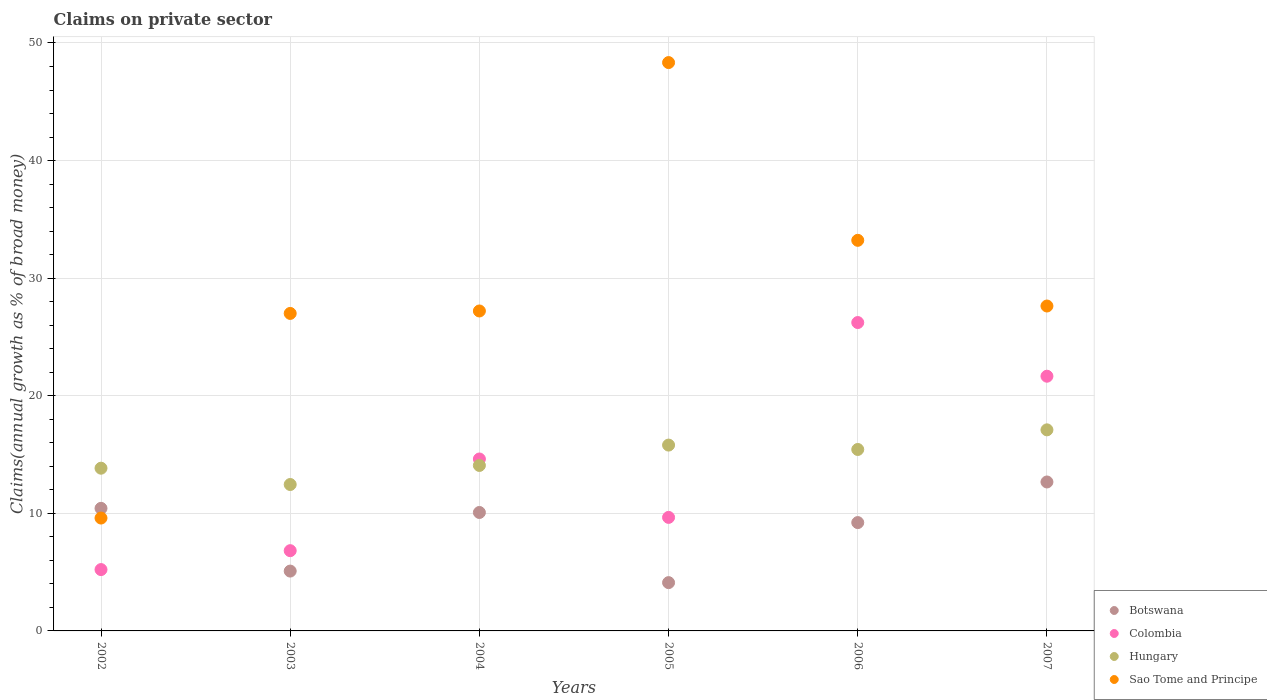Is the number of dotlines equal to the number of legend labels?
Give a very brief answer. Yes. What is the percentage of broad money claimed on private sector in Sao Tome and Principe in 2002?
Provide a succinct answer. 9.6. Across all years, what is the maximum percentage of broad money claimed on private sector in Colombia?
Your response must be concise. 26.22. Across all years, what is the minimum percentage of broad money claimed on private sector in Botswana?
Provide a short and direct response. 4.11. In which year was the percentage of broad money claimed on private sector in Hungary maximum?
Keep it short and to the point. 2007. What is the total percentage of broad money claimed on private sector in Botswana in the graph?
Provide a short and direct response. 51.57. What is the difference between the percentage of broad money claimed on private sector in Botswana in 2003 and that in 2006?
Your response must be concise. -4.12. What is the difference between the percentage of broad money claimed on private sector in Sao Tome and Principe in 2006 and the percentage of broad money claimed on private sector in Hungary in 2004?
Offer a terse response. 19.14. What is the average percentage of broad money claimed on private sector in Hungary per year?
Your response must be concise. 14.78. In the year 2005, what is the difference between the percentage of broad money claimed on private sector in Colombia and percentage of broad money claimed on private sector in Hungary?
Provide a short and direct response. -6.15. What is the ratio of the percentage of broad money claimed on private sector in Colombia in 2003 to that in 2006?
Provide a succinct answer. 0.26. Is the difference between the percentage of broad money claimed on private sector in Colombia in 2005 and 2006 greater than the difference between the percentage of broad money claimed on private sector in Hungary in 2005 and 2006?
Provide a short and direct response. No. What is the difference between the highest and the second highest percentage of broad money claimed on private sector in Colombia?
Ensure brevity in your answer.  4.56. What is the difference between the highest and the lowest percentage of broad money claimed on private sector in Colombia?
Make the answer very short. 21.01. In how many years, is the percentage of broad money claimed on private sector in Hungary greater than the average percentage of broad money claimed on private sector in Hungary taken over all years?
Your response must be concise. 3. Is the sum of the percentage of broad money claimed on private sector in Colombia in 2004 and 2005 greater than the maximum percentage of broad money claimed on private sector in Sao Tome and Principe across all years?
Ensure brevity in your answer.  No. Does the percentage of broad money claimed on private sector in Sao Tome and Principe monotonically increase over the years?
Your answer should be compact. No. Is the percentage of broad money claimed on private sector in Colombia strictly less than the percentage of broad money claimed on private sector in Botswana over the years?
Your answer should be compact. No. How many years are there in the graph?
Your answer should be compact. 6. Does the graph contain grids?
Your answer should be very brief. Yes. Where does the legend appear in the graph?
Give a very brief answer. Bottom right. How are the legend labels stacked?
Your response must be concise. Vertical. What is the title of the graph?
Make the answer very short. Claims on private sector. Does "Sudan" appear as one of the legend labels in the graph?
Make the answer very short. No. What is the label or title of the X-axis?
Provide a succinct answer. Years. What is the label or title of the Y-axis?
Your answer should be very brief. Claims(annual growth as % of broad money). What is the Claims(annual growth as % of broad money) in Botswana in 2002?
Provide a succinct answer. 10.42. What is the Claims(annual growth as % of broad money) of Colombia in 2002?
Provide a succinct answer. 5.22. What is the Claims(annual growth as % of broad money) in Hungary in 2002?
Ensure brevity in your answer.  13.84. What is the Claims(annual growth as % of broad money) in Sao Tome and Principe in 2002?
Your answer should be very brief. 9.6. What is the Claims(annual growth as % of broad money) in Botswana in 2003?
Provide a short and direct response. 5.09. What is the Claims(annual growth as % of broad money) in Colombia in 2003?
Offer a terse response. 6.82. What is the Claims(annual growth as % of broad money) in Hungary in 2003?
Your answer should be compact. 12.45. What is the Claims(annual growth as % of broad money) in Sao Tome and Principe in 2003?
Your answer should be very brief. 27. What is the Claims(annual growth as % of broad money) in Botswana in 2004?
Ensure brevity in your answer.  10.07. What is the Claims(annual growth as % of broad money) in Colombia in 2004?
Offer a terse response. 14.62. What is the Claims(annual growth as % of broad money) of Hungary in 2004?
Give a very brief answer. 14.07. What is the Claims(annual growth as % of broad money) in Sao Tome and Principe in 2004?
Ensure brevity in your answer.  27.21. What is the Claims(annual growth as % of broad money) in Botswana in 2005?
Your answer should be compact. 4.11. What is the Claims(annual growth as % of broad money) in Colombia in 2005?
Offer a very short reply. 9.66. What is the Claims(annual growth as % of broad money) of Hungary in 2005?
Offer a very short reply. 15.8. What is the Claims(annual growth as % of broad money) of Sao Tome and Principe in 2005?
Offer a very short reply. 48.33. What is the Claims(annual growth as % of broad money) of Botswana in 2006?
Ensure brevity in your answer.  9.21. What is the Claims(annual growth as % of broad money) in Colombia in 2006?
Your answer should be very brief. 26.22. What is the Claims(annual growth as % of broad money) in Hungary in 2006?
Give a very brief answer. 15.43. What is the Claims(annual growth as % of broad money) of Sao Tome and Principe in 2006?
Your answer should be compact. 33.22. What is the Claims(annual growth as % of broad money) of Botswana in 2007?
Your answer should be compact. 12.67. What is the Claims(annual growth as % of broad money) of Colombia in 2007?
Provide a short and direct response. 21.66. What is the Claims(annual growth as % of broad money) in Hungary in 2007?
Your answer should be very brief. 17.1. What is the Claims(annual growth as % of broad money) of Sao Tome and Principe in 2007?
Make the answer very short. 27.63. Across all years, what is the maximum Claims(annual growth as % of broad money) of Botswana?
Offer a very short reply. 12.67. Across all years, what is the maximum Claims(annual growth as % of broad money) in Colombia?
Offer a very short reply. 26.22. Across all years, what is the maximum Claims(annual growth as % of broad money) of Hungary?
Provide a succinct answer. 17.1. Across all years, what is the maximum Claims(annual growth as % of broad money) in Sao Tome and Principe?
Ensure brevity in your answer.  48.33. Across all years, what is the minimum Claims(annual growth as % of broad money) in Botswana?
Provide a short and direct response. 4.11. Across all years, what is the minimum Claims(annual growth as % of broad money) in Colombia?
Provide a succinct answer. 5.22. Across all years, what is the minimum Claims(annual growth as % of broad money) of Hungary?
Your answer should be compact. 12.45. Across all years, what is the minimum Claims(annual growth as % of broad money) of Sao Tome and Principe?
Your response must be concise. 9.6. What is the total Claims(annual growth as % of broad money) of Botswana in the graph?
Provide a succinct answer. 51.57. What is the total Claims(annual growth as % of broad money) of Colombia in the graph?
Your answer should be compact. 84.2. What is the total Claims(annual growth as % of broad money) in Hungary in the graph?
Provide a short and direct response. 88.7. What is the total Claims(annual growth as % of broad money) of Sao Tome and Principe in the graph?
Your answer should be compact. 172.99. What is the difference between the Claims(annual growth as % of broad money) in Botswana in 2002 and that in 2003?
Make the answer very short. 5.34. What is the difference between the Claims(annual growth as % of broad money) in Colombia in 2002 and that in 2003?
Provide a short and direct response. -1.61. What is the difference between the Claims(annual growth as % of broad money) of Hungary in 2002 and that in 2003?
Provide a short and direct response. 1.39. What is the difference between the Claims(annual growth as % of broad money) of Sao Tome and Principe in 2002 and that in 2003?
Offer a terse response. -17.4. What is the difference between the Claims(annual growth as % of broad money) of Botswana in 2002 and that in 2004?
Provide a short and direct response. 0.35. What is the difference between the Claims(annual growth as % of broad money) of Colombia in 2002 and that in 2004?
Offer a terse response. -9.4. What is the difference between the Claims(annual growth as % of broad money) of Hungary in 2002 and that in 2004?
Make the answer very short. -0.23. What is the difference between the Claims(annual growth as % of broad money) of Sao Tome and Principe in 2002 and that in 2004?
Offer a very short reply. -17.61. What is the difference between the Claims(annual growth as % of broad money) of Botswana in 2002 and that in 2005?
Make the answer very short. 6.32. What is the difference between the Claims(annual growth as % of broad money) in Colombia in 2002 and that in 2005?
Make the answer very short. -4.44. What is the difference between the Claims(annual growth as % of broad money) of Hungary in 2002 and that in 2005?
Your response must be concise. -1.97. What is the difference between the Claims(annual growth as % of broad money) of Sao Tome and Principe in 2002 and that in 2005?
Ensure brevity in your answer.  -38.73. What is the difference between the Claims(annual growth as % of broad money) of Botswana in 2002 and that in 2006?
Keep it short and to the point. 1.21. What is the difference between the Claims(annual growth as % of broad money) in Colombia in 2002 and that in 2006?
Your answer should be compact. -21.01. What is the difference between the Claims(annual growth as % of broad money) in Hungary in 2002 and that in 2006?
Provide a succinct answer. -1.59. What is the difference between the Claims(annual growth as % of broad money) of Sao Tome and Principe in 2002 and that in 2006?
Ensure brevity in your answer.  -23.62. What is the difference between the Claims(annual growth as % of broad money) in Botswana in 2002 and that in 2007?
Your answer should be compact. -2.24. What is the difference between the Claims(annual growth as % of broad money) of Colombia in 2002 and that in 2007?
Provide a succinct answer. -16.44. What is the difference between the Claims(annual growth as % of broad money) in Hungary in 2002 and that in 2007?
Offer a very short reply. -3.26. What is the difference between the Claims(annual growth as % of broad money) of Sao Tome and Principe in 2002 and that in 2007?
Offer a terse response. -18.03. What is the difference between the Claims(annual growth as % of broad money) of Botswana in 2003 and that in 2004?
Your answer should be very brief. -4.98. What is the difference between the Claims(annual growth as % of broad money) in Colombia in 2003 and that in 2004?
Provide a succinct answer. -7.8. What is the difference between the Claims(annual growth as % of broad money) in Hungary in 2003 and that in 2004?
Give a very brief answer. -1.62. What is the difference between the Claims(annual growth as % of broad money) of Sao Tome and Principe in 2003 and that in 2004?
Your answer should be compact. -0.21. What is the difference between the Claims(annual growth as % of broad money) of Botswana in 2003 and that in 2005?
Your answer should be very brief. 0.98. What is the difference between the Claims(annual growth as % of broad money) of Colombia in 2003 and that in 2005?
Offer a terse response. -2.83. What is the difference between the Claims(annual growth as % of broad money) of Hungary in 2003 and that in 2005?
Offer a very short reply. -3.35. What is the difference between the Claims(annual growth as % of broad money) in Sao Tome and Principe in 2003 and that in 2005?
Make the answer very short. -21.33. What is the difference between the Claims(annual growth as % of broad money) of Botswana in 2003 and that in 2006?
Offer a very short reply. -4.12. What is the difference between the Claims(annual growth as % of broad money) of Colombia in 2003 and that in 2006?
Provide a succinct answer. -19.4. What is the difference between the Claims(annual growth as % of broad money) of Hungary in 2003 and that in 2006?
Provide a succinct answer. -2.98. What is the difference between the Claims(annual growth as % of broad money) of Sao Tome and Principe in 2003 and that in 2006?
Offer a terse response. -6.22. What is the difference between the Claims(annual growth as % of broad money) of Botswana in 2003 and that in 2007?
Offer a very short reply. -7.58. What is the difference between the Claims(annual growth as % of broad money) in Colombia in 2003 and that in 2007?
Make the answer very short. -14.84. What is the difference between the Claims(annual growth as % of broad money) of Hungary in 2003 and that in 2007?
Ensure brevity in your answer.  -4.65. What is the difference between the Claims(annual growth as % of broad money) in Sao Tome and Principe in 2003 and that in 2007?
Give a very brief answer. -0.63. What is the difference between the Claims(annual growth as % of broad money) in Botswana in 2004 and that in 2005?
Provide a short and direct response. 5.97. What is the difference between the Claims(annual growth as % of broad money) of Colombia in 2004 and that in 2005?
Give a very brief answer. 4.97. What is the difference between the Claims(annual growth as % of broad money) in Hungary in 2004 and that in 2005?
Offer a very short reply. -1.73. What is the difference between the Claims(annual growth as % of broad money) in Sao Tome and Principe in 2004 and that in 2005?
Provide a succinct answer. -21.12. What is the difference between the Claims(annual growth as % of broad money) of Botswana in 2004 and that in 2006?
Provide a short and direct response. 0.86. What is the difference between the Claims(annual growth as % of broad money) in Colombia in 2004 and that in 2006?
Your response must be concise. -11.6. What is the difference between the Claims(annual growth as % of broad money) in Hungary in 2004 and that in 2006?
Your answer should be very brief. -1.36. What is the difference between the Claims(annual growth as % of broad money) of Sao Tome and Principe in 2004 and that in 2006?
Keep it short and to the point. -6.01. What is the difference between the Claims(annual growth as % of broad money) in Botswana in 2004 and that in 2007?
Give a very brief answer. -2.59. What is the difference between the Claims(annual growth as % of broad money) in Colombia in 2004 and that in 2007?
Your answer should be very brief. -7.04. What is the difference between the Claims(annual growth as % of broad money) of Hungary in 2004 and that in 2007?
Your answer should be compact. -3.03. What is the difference between the Claims(annual growth as % of broad money) in Sao Tome and Principe in 2004 and that in 2007?
Provide a succinct answer. -0.42. What is the difference between the Claims(annual growth as % of broad money) of Botswana in 2005 and that in 2006?
Your response must be concise. -5.11. What is the difference between the Claims(annual growth as % of broad money) of Colombia in 2005 and that in 2006?
Keep it short and to the point. -16.57. What is the difference between the Claims(annual growth as % of broad money) in Hungary in 2005 and that in 2006?
Provide a short and direct response. 0.37. What is the difference between the Claims(annual growth as % of broad money) in Sao Tome and Principe in 2005 and that in 2006?
Provide a succinct answer. 15.12. What is the difference between the Claims(annual growth as % of broad money) in Botswana in 2005 and that in 2007?
Make the answer very short. -8.56. What is the difference between the Claims(annual growth as % of broad money) of Colombia in 2005 and that in 2007?
Provide a short and direct response. -12.01. What is the difference between the Claims(annual growth as % of broad money) in Hungary in 2005 and that in 2007?
Your answer should be compact. -1.3. What is the difference between the Claims(annual growth as % of broad money) in Sao Tome and Principe in 2005 and that in 2007?
Offer a terse response. 20.7. What is the difference between the Claims(annual growth as % of broad money) in Botswana in 2006 and that in 2007?
Make the answer very short. -3.45. What is the difference between the Claims(annual growth as % of broad money) in Colombia in 2006 and that in 2007?
Ensure brevity in your answer.  4.56. What is the difference between the Claims(annual growth as % of broad money) of Hungary in 2006 and that in 2007?
Keep it short and to the point. -1.67. What is the difference between the Claims(annual growth as % of broad money) in Sao Tome and Principe in 2006 and that in 2007?
Offer a very short reply. 5.59. What is the difference between the Claims(annual growth as % of broad money) of Botswana in 2002 and the Claims(annual growth as % of broad money) of Colombia in 2003?
Offer a very short reply. 3.6. What is the difference between the Claims(annual growth as % of broad money) in Botswana in 2002 and the Claims(annual growth as % of broad money) in Hungary in 2003?
Ensure brevity in your answer.  -2.03. What is the difference between the Claims(annual growth as % of broad money) in Botswana in 2002 and the Claims(annual growth as % of broad money) in Sao Tome and Principe in 2003?
Keep it short and to the point. -16.58. What is the difference between the Claims(annual growth as % of broad money) in Colombia in 2002 and the Claims(annual growth as % of broad money) in Hungary in 2003?
Provide a short and direct response. -7.24. What is the difference between the Claims(annual growth as % of broad money) in Colombia in 2002 and the Claims(annual growth as % of broad money) in Sao Tome and Principe in 2003?
Give a very brief answer. -21.78. What is the difference between the Claims(annual growth as % of broad money) in Hungary in 2002 and the Claims(annual growth as % of broad money) in Sao Tome and Principe in 2003?
Ensure brevity in your answer.  -13.16. What is the difference between the Claims(annual growth as % of broad money) in Botswana in 2002 and the Claims(annual growth as % of broad money) in Colombia in 2004?
Give a very brief answer. -4.2. What is the difference between the Claims(annual growth as % of broad money) of Botswana in 2002 and the Claims(annual growth as % of broad money) of Hungary in 2004?
Give a very brief answer. -3.65. What is the difference between the Claims(annual growth as % of broad money) in Botswana in 2002 and the Claims(annual growth as % of broad money) in Sao Tome and Principe in 2004?
Offer a terse response. -16.78. What is the difference between the Claims(annual growth as % of broad money) in Colombia in 2002 and the Claims(annual growth as % of broad money) in Hungary in 2004?
Make the answer very short. -8.86. What is the difference between the Claims(annual growth as % of broad money) of Colombia in 2002 and the Claims(annual growth as % of broad money) of Sao Tome and Principe in 2004?
Provide a short and direct response. -21.99. What is the difference between the Claims(annual growth as % of broad money) in Hungary in 2002 and the Claims(annual growth as % of broad money) in Sao Tome and Principe in 2004?
Give a very brief answer. -13.37. What is the difference between the Claims(annual growth as % of broad money) of Botswana in 2002 and the Claims(annual growth as % of broad money) of Colombia in 2005?
Offer a very short reply. 0.77. What is the difference between the Claims(annual growth as % of broad money) in Botswana in 2002 and the Claims(annual growth as % of broad money) in Hungary in 2005?
Provide a succinct answer. -5.38. What is the difference between the Claims(annual growth as % of broad money) in Botswana in 2002 and the Claims(annual growth as % of broad money) in Sao Tome and Principe in 2005?
Ensure brevity in your answer.  -37.91. What is the difference between the Claims(annual growth as % of broad money) of Colombia in 2002 and the Claims(annual growth as % of broad money) of Hungary in 2005?
Provide a short and direct response. -10.59. What is the difference between the Claims(annual growth as % of broad money) of Colombia in 2002 and the Claims(annual growth as % of broad money) of Sao Tome and Principe in 2005?
Provide a short and direct response. -43.12. What is the difference between the Claims(annual growth as % of broad money) of Hungary in 2002 and the Claims(annual growth as % of broad money) of Sao Tome and Principe in 2005?
Keep it short and to the point. -34.49. What is the difference between the Claims(annual growth as % of broad money) of Botswana in 2002 and the Claims(annual growth as % of broad money) of Colombia in 2006?
Give a very brief answer. -15.8. What is the difference between the Claims(annual growth as % of broad money) of Botswana in 2002 and the Claims(annual growth as % of broad money) of Hungary in 2006?
Your answer should be very brief. -5.01. What is the difference between the Claims(annual growth as % of broad money) in Botswana in 2002 and the Claims(annual growth as % of broad money) in Sao Tome and Principe in 2006?
Offer a terse response. -22.79. What is the difference between the Claims(annual growth as % of broad money) in Colombia in 2002 and the Claims(annual growth as % of broad money) in Hungary in 2006?
Ensure brevity in your answer.  -10.21. What is the difference between the Claims(annual growth as % of broad money) in Colombia in 2002 and the Claims(annual growth as % of broad money) in Sao Tome and Principe in 2006?
Offer a very short reply. -28. What is the difference between the Claims(annual growth as % of broad money) of Hungary in 2002 and the Claims(annual growth as % of broad money) of Sao Tome and Principe in 2006?
Your response must be concise. -19.38. What is the difference between the Claims(annual growth as % of broad money) in Botswana in 2002 and the Claims(annual growth as % of broad money) in Colombia in 2007?
Make the answer very short. -11.24. What is the difference between the Claims(annual growth as % of broad money) in Botswana in 2002 and the Claims(annual growth as % of broad money) in Hungary in 2007?
Provide a short and direct response. -6.68. What is the difference between the Claims(annual growth as % of broad money) in Botswana in 2002 and the Claims(annual growth as % of broad money) in Sao Tome and Principe in 2007?
Make the answer very short. -17.21. What is the difference between the Claims(annual growth as % of broad money) of Colombia in 2002 and the Claims(annual growth as % of broad money) of Hungary in 2007?
Make the answer very short. -11.88. What is the difference between the Claims(annual growth as % of broad money) in Colombia in 2002 and the Claims(annual growth as % of broad money) in Sao Tome and Principe in 2007?
Your answer should be compact. -22.41. What is the difference between the Claims(annual growth as % of broad money) of Hungary in 2002 and the Claims(annual growth as % of broad money) of Sao Tome and Principe in 2007?
Make the answer very short. -13.79. What is the difference between the Claims(annual growth as % of broad money) in Botswana in 2003 and the Claims(annual growth as % of broad money) in Colombia in 2004?
Your answer should be compact. -9.53. What is the difference between the Claims(annual growth as % of broad money) in Botswana in 2003 and the Claims(annual growth as % of broad money) in Hungary in 2004?
Your response must be concise. -8.98. What is the difference between the Claims(annual growth as % of broad money) of Botswana in 2003 and the Claims(annual growth as % of broad money) of Sao Tome and Principe in 2004?
Give a very brief answer. -22.12. What is the difference between the Claims(annual growth as % of broad money) in Colombia in 2003 and the Claims(annual growth as % of broad money) in Hungary in 2004?
Offer a very short reply. -7.25. What is the difference between the Claims(annual growth as % of broad money) in Colombia in 2003 and the Claims(annual growth as % of broad money) in Sao Tome and Principe in 2004?
Your answer should be compact. -20.38. What is the difference between the Claims(annual growth as % of broad money) in Hungary in 2003 and the Claims(annual growth as % of broad money) in Sao Tome and Principe in 2004?
Your answer should be compact. -14.76. What is the difference between the Claims(annual growth as % of broad money) in Botswana in 2003 and the Claims(annual growth as % of broad money) in Colombia in 2005?
Provide a short and direct response. -4.57. What is the difference between the Claims(annual growth as % of broad money) in Botswana in 2003 and the Claims(annual growth as % of broad money) in Hungary in 2005?
Offer a very short reply. -10.72. What is the difference between the Claims(annual growth as % of broad money) of Botswana in 2003 and the Claims(annual growth as % of broad money) of Sao Tome and Principe in 2005?
Your answer should be very brief. -43.24. What is the difference between the Claims(annual growth as % of broad money) in Colombia in 2003 and the Claims(annual growth as % of broad money) in Hungary in 2005?
Ensure brevity in your answer.  -8.98. What is the difference between the Claims(annual growth as % of broad money) of Colombia in 2003 and the Claims(annual growth as % of broad money) of Sao Tome and Principe in 2005?
Offer a terse response. -41.51. What is the difference between the Claims(annual growth as % of broad money) in Hungary in 2003 and the Claims(annual growth as % of broad money) in Sao Tome and Principe in 2005?
Offer a very short reply. -35.88. What is the difference between the Claims(annual growth as % of broad money) of Botswana in 2003 and the Claims(annual growth as % of broad money) of Colombia in 2006?
Give a very brief answer. -21.14. What is the difference between the Claims(annual growth as % of broad money) in Botswana in 2003 and the Claims(annual growth as % of broad money) in Hungary in 2006?
Keep it short and to the point. -10.34. What is the difference between the Claims(annual growth as % of broad money) of Botswana in 2003 and the Claims(annual growth as % of broad money) of Sao Tome and Principe in 2006?
Make the answer very short. -28.13. What is the difference between the Claims(annual growth as % of broad money) of Colombia in 2003 and the Claims(annual growth as % of broad money) of Hungary in 2006?
Provide a succinct answer. -8.61. What is the difference between the Claims(annual growth as % of broad money) in Colombia in 2003 and the Claims(annual growth as % of broad money) in Sao Tome and Principe in 2006?
Offer a terse response. -26.39. What is the difference between the Claims(annual growth as % of broad money) of Hungary in 2003 and the Claims(annual growth as % of broad money) of Sao Tome and Principe in 2006?
Ensure brevity in your answer.  -20.77. What is the difference between the Claims(annual growth as % of broad money) of Botswana in 2003 and the Claims(annual growth as % of broad money) of Colombia in 2007?
Your response must be concise. -16.57. What is the difference between the Claims(annual growth as % of broad money) of Botswana in 2003 and the Claims(annual growth as % of broad money) of Hungary in 2007?
Provide a succinct answer. -12.01. What is the difference between the Claims(annual growth as % of broad money) of Botswana in 2003 and the Claims(annual growth as % of broad money) of Sao Tome and Principe in 2007?
Your response must be concise. -22.54. What is the difference between the Claims(annual growth as % of broad money) in Colombia in 2003 and the Claims(annual growth as % of broad money) in Hungary in 2007?
Offer a terse response. -10.28. What is the difference between the Claims(annual growth as % of broad money) of Colombia in 2003 and the Claims(annual growth as % of broad money) of Sao Tome and Principe in 2007?
Make the answer very short. -20.81. What is the difference between the Claims(annual growth as % of broad money) of Hungary in 2003 and the Claims(annual growth as % of broad money) of Sao Tome and Principe in 2007?
Offer a terse response. -15.18. What is the difference between the Claims(annual growth as % of broad money) in Botswana in 2004 and the Claims(annual growth as % of broad money) in Colombia in 2005?
Provide a short and direct response. 0.42. What is the difference between the Claims(annual growth as % of broad money) in Botswana in 2004 and the Claims(annual growth as % of broad money) in Hungary in 2005?
Provide a succinct answer. -5.73. What is the difference between the Claims(annual growth as % of broad money) in Botswana in 2004 and the Claims(annual growth as % of broad money) in Sao Tome and Principe in 2005?
Keep it short and to the point. -38.26. What is the difference between the Claims(annual growth as % of broad money) of Colombia in 2004 and the Claims(annual growth as % of broad money) of Hungary in 2005?
Provide a succinct answer. -1.18. What is the difference between the Claims(annual growth as % of broad money) in Colombia in 2004 and the Claims(annual growth as % of broad money) in Sao Tome and Principe in 2005?
Give a very brief answer. -33.71. What is the difference between the Claims(annual growth as % of broad money) of Hungary in 2004 and the Claims(annual growth as % of broad money) of Sao Tome and Principe in 2005?
Your answer should be compact. -34.26. What is the difference between the Claims(annual growth as % of broad money) in Botswana in 2004 and the Claims(annual growth as % of broad money) in Colombia in 2006?
Make the answer very short. -16.15. What is the difference between the Claims(annual growth as % of broad money) in Botswana in 2004 and the Claims(annual growth as % of broad money) in Hungary in 2006?
Make the answer very short. -5.36. What is the difference between the Claims(annual growth as % of broad money) of Botswana in 2004 and the Claims(annual growth as % of broad money) of Sao Tome and Principe in 2006?
Make the answer very short. -23.14. What is the difference between the Claims(annual growth as % of broad money) of Colombia in 2004 and the Claims(annual growth as % of broad money) of Hungary in 2006?
Ensure brevity in your answer.  -0.81. What is the difference between the Claims(annual growth as % of broad money) in Colombia in 2004 and the Claims(annual growth as % of broad money) in Sao Tome and Principe in 2006?
Offer a very short reply. -18.6. What is the difference between the Claims(annual growth as % of broad money) in Hungary in 2004 and the Claims(annual growth as % of broad money) in Sao Tome and Principe in 2006?
Make the answer very short. -19.14. What is the difference between the Claims(annual growth as % of broad money) in Botswana in 2004 and the Claims(annual growth as % of broad money) in Colombia in 2007?
Offer a terse response. -11.59. What is the difference between the Claims(annual growth as % of broad money) in Botswana in 2004 and the Claims(annual growth as % of broad money) in Hungary in 2007?
Your response must be concise. -7.03. What is the difference between the Claims(annual growth as % of broad money) in Botswana in 2004 and the Claims(annual growth as % of broad money) in Sao Tome and Principe in 2007?
Your response must be concise. -17.56. What is the difference between the Claims(annual growth as % of broad money) in Colombia in 2004 and the Claims(annual growth as % of broad money) in Hungary in 2007?
Your response must be concise. -2.48. What is the difference between the Claims(annual growth as % of broad money) in Colombia in 2004 and the Claims(annual growth as % of broad money) in Sao Tome and Principe in 2007?
Your response must be concise. -13.01. What is the difference between the Claims(annual growth as % of broad money) in Hungary in 2004 and the Claims(annual growth as % of broad money) in Sao Tome and Principe in 2007?
Offer a very short reply. -13.56. What is the difference between the Claims(annual growth as % of broad money) of Botswana in 2005 and the Claims(annual growth as % of broad money) of Colombia in 2006?
Offer a very short reply. -22.12. What is the difference between the Claims(annual growth as % of broad money) of Botswana in 2005 and the Claims(annual growth as % of broad money) of Hungary in 2006?
Provide a short and direct response. -11.32. What is the difference between the Claims(annual growth as % of broad money) of Botswana in 2005 and the Claims(annual growth as % of broad money) of Sao Tome and Principe in 2006?
Make the answer very short. -29.11. What is the difference between the Claims(annual growth as % of broad money) of Colombia in 2005 and the Claims(annual growth as % of broad money) of Hungary in 2006?
Keep it short and to the point. -5.78. What is the difference between the Claims(annual growth as % of broad money) of Colombia in 2005 and the Claims(annual growth as % of broad money) of Sao Tome and Principe in 2006?
Offer a terse response. -23.56. What is the difference between the Claims(annual growth as % of broad money) of Hungary in 2005 and the Claims(annual growth as % of broad money) of Sao Tome and Principe in 2006?
Offer a terse response. -17.41. What is the difference between the Claims(annual growth as % of broad money) of Botswana in 2005 and the Claims(annual growth as % of broad money) of Colombia in 2007?
Make the answer very short. -17.55. What is the difference between the Claims(annual growth as % of broad money) of Botswana in 2005 and the Claims(annual growth as % of broad money) of Hungary in 2007?
Make the answer very short. -12.99. What is the difference between the Claims(annual growth as % of broad money) in Botswana in 2005 and the Claims(annual growth as % of broad money) in Sao Tome and Principe in 2007?
Your answer should be very brief. -23.52. What is the difference between the Claims(annual growth as % of broad money) in Colombia in 2005 and the Claims(annual growth as % of broad money) in Hungary in 2007?
Provide a succinct answer. -7.44. What is the difference between the Claims(annual growth as % of broad money) of Colombia in 2005 and the Claims(annual growth as % of broad money) of Sao Tome and Principe in 2007?
Provide a succinct answer. -17.98. What is the difference between the Claims(annual growth as % of broad money) in Hungary in 2005 and the Claims(annual growth as % of broad money) in Sao Tome and Principe in 2007?
Your answer should be very brief. -11.83. What is the difference between the Claims(annual growth as % of broad money) in Botswana in 2006 and the Claims(annual growth as % of broad money) in Colombia in 2007?
Keep it short and to the point. -12.45. What is the difference between the Claims(annual growth as % of broad money) of Botswana in 2006 and the Claims(annual growth as % of broad money) of Hungary in 2007?
Provide a succinct answer. -7.89. What is the difference between the Claims(annual growth as % of broad money) in Botswana in 2006 and the Claims(annual growth as % of broad money) in Sao Tome and Principe in 2007?
Make the answer very short. -18.42. What is the difference between the Claims(annual growth as % of broad money) in Colombia in 2006 and the Claims(annual growth as % of broad money) in Hungary in 2007?
Offer a very short reply. 9.13. What is the difference between the Claims(annual growth as % of broad money) in Colombia in 2006 and the Claims(annual growth as % of broad money) in Sao Tome and Principe in 2007?
Your response must be concise. -1.41. What is the difference between the Claims(annual growth as % of broad money) in Hungary in 2006 and the Claims(annual growth as % of broad money) in Sao Tome and Principe in 2007?
Your answer should be compact. -12.2. What is the average Claims(annual growth as % of broad money) in Botswana per year?
Provide a succinct answer. 8.6. What is the average Claims(annual growth as % of broad money) in Colombia per year?
Your response must be concise. 14.03. What is the average Claims(annual growth as % of broad money) in Hungary per year?
Offer a terse response. 14.78. What is the average Claims(annual growth as % of broad money) of Sao Tome and Principe per year?
Give a very brief answer. 28.83. In the year 2002, what is the difference between the Claims(annual growth as % of broad money) in Botswana and Claims(annual growth as % of broad money) in Colombia?
Offer a terse response. 5.21. In the year 2002, what is the difference between the Claims(annual growth as % of broad money) in Botswana and Claims(annual growth as % of broad money) in Hungary?
Provide a short and direct response. -3.41. In the year 2002, what is the difference between the Claims(annual growth as % of broad money) in Botswana and Claims(annual growth as % of broad money) in Sao Tome and Principe?
Your answer should be very brief. 0.83. In the year 2002, what is the difference between the Claims(annual growth as % of broad money) of Colombia and Claims(annual growth as % of broad money) of Hungary?
Keep it short and to the point. -8.62. In the year 2002, what is the difference between the Claims(annual growth as % of broad money) in Colombia and Claims(annual growth as % of broad money) in Sao Tome and Principe?
Your answer should be very brief. -4.38. In the year 2002, what is the difference between the Claims(annual growth as % of broad money) in Hungary and Claims(annual growth as % of broad money) in Sao Tome and Principe?
Your answer should be very brief. 4.24. In the year 2003, what is the difference between the Claims(annual growth as % of broad money) in Botswana and Claims(annual growth as % of broad money) in Colombia?
Offer a very short reply. -1.74. In the year 2003, what is the difference between the Claims(annual growth as % of broad money) in Botswana and Claims(annual growth as % of broad money) in Hungary?
Offer a very short reply. -7.36. In the year 2003, what is the difference between the Claims(annual growth as % of broad money) in Botswana and Claims(annual growth as % of broad money) in Sao Tome and Principe?
Keep it short and to the point. -21.91. In the year 2003, what is the difference between the Claims(annual growth as % of broad money) of Colombia and Claims(annual growth as % of broad money) of Hungary?
Your answer should be very brief. -5.63. In the year 2003, what is the difference between the Claims(annual growth as % of broad money) in Colombia and Claims(annual growth as % of broad money) in Sao Tome and Principe?
Offer a terse response. -20.18. In the year 2003, what is the difference between the Claims(annual growth as % of broad money) in Hungary and Claims(annual growth as % of broad money) in Sao Tome and Principe?
Your answer should be compact. -14.55. In the year 2004, what is the difference between the Claims(annual growth as % of broad money) of Botswana and Claims(annual growth as % of broad money) of Colombia?
Provide a succinct answer. -4.55. In the year 2004, what is the difference between the Claims(annual growth as % of broad money) of Botswana and Claims(annual growth as % of broad money) of Sao Tome and Principe?
Your answer should be very brief. -17.14. In the year 2004, what is the difference between the Claims(annual growth as % of broad money) of Colombia and Claims(annual growth as % of broad money) of Hungary?
Offer a terse response. 0.55. In the year 2004, what is the difference between the Claims(annual growth as % of broad money) of Colombia and Claims(annual growth as % of broad money) of Sao Tome and Principe?
Offer a very short reply. -12.59. In the year 2004, what is the difference between the Claims(annual growth as % of broad money) of Hungary and Claims(annual growth as % of broad money) of Sao Tome and Principe?
Make the answer very short. -13.14. In the year 2005, what is the difference between the Claims(annual growth as % of broad money) in Botswana and Claims(annual growth as % of broad money) in Colombia?
Your answer should be very brief. -5.55. In the year 2005, what is the difference between the Claims(annual growth as % of broad money) in Botswana and Claims(annual growth as % of broad money) in Hungary?
Your answer should be compact. -11.7. In the year 2005, what is the difference between the Claims(annual growth as % of broad money) of Botswana and Claims(annual growth as % of broad money) of Sao Tome and Principe?
Your answer should be compact. -44.23. In the year 2005, what is the difference between the Claims(annual growth as % of broad money) of Colombia and Claims(annual growth as % of broad money) of Hungary?
Ensure brevity in your answer.  -6.15. In the year 2005, what is the difference between the Claims(annual growth as % of broad money) of Colombia and Claims(annual growth as % of broad money) of Sao Tome and Principe?
Keep it short and to the point. -38.68. In the year 2005, what is the difference between the Claims(annual growth as % of broad money) of Hungary and Claims(annual growth as % of broad money) of Sao Tome and Principe?
Your answer should be very brief. -32.53. In the year 2006, what is the difference between the Claims(annual growth as % of broad money) of Botswana and Claims(annual growth as % of broad money) of Colombia?
Your answer should be very brief. -17.01. In the year 2006, what is the difference between the Claims(annual growth as % of broad money) in Botswana and Claims(annual growth as % of broad money) in Hungary?
Your answer should be compact. -6.22. In the year 2006, what is the difference between the Claims(annual growth as % of broad money) in Botswana and Claims(annual growth as % of broad money) in Sao Tome and Principe?
Ensure brevity in your answer.  -24. In the year 2006, what is the difference between the Claims(annual growth as % of broad money) in Colombia and Claims(annual growth as % of broad money) in Hungary?
Keep it short and to the point. 10.79. In the year 2006, what is the difference between the Claims(annual growth as % of broad money) of Colombia and Claims(annual growth as % of broad money) of Sao Tome and Principe?
Provide a succinct answer. -6.99. In the year 2006, what is the difference between the Claims(annual growth as % of broad money) of Hungary and Claims(annual growth as % of broad money) of Sao Tome and Principe?
Your answer should be very brief. -17.79. In the year 2007, what is the difference between the Claims(annual growth as % of broad money) in Botswana and Claims(annual growth as % of broad money) in Colombia?
Provide a succinct answer. -8.99. In the year 2007, what is the difference between the Claims(annual growth as % of broad money) in Botswana and Claims(annual growth as % of broad money) in Hungary?
Make the answer very short. -4.43. In the year 2007, what is the difference between the Claims(annual growth as % of broad money) of Botswana and Claims(annual growth as % of broad money) of Sao Tome and Principe?
Offer a terse response. -14.96. In the year 2007, what is the difference between the Claims(annual growth as % of broad money) of Colombia and Claims(annual growth as % of broad money) of Hungary?
Your answer should be very brief. 4.56. In the year 2007, what is the difference between the Claims(annual growth as % of broad money) of Colombia and Claims(annual growth as % of broad money) of Sao Tome and Principe?
Offer a terse response. -5.97. In the year 2007, what is the difference between the Claims(annual growth as % of broad money) of Hungary and Claims(annual growth as % of broad money) of Sao Tome and Principe?
Provide a short and direct response. -10.53. What is the ratio of the Claims(annual growth as % of broad money) of Botswana in 2002 to that in 2003?
Your answer should be compact. 2.05. What is the ratio of the Claims(annual growth as % of broad money) in Colombia in 2002 to that in 2003?
Your response must be concise. 0.76. What is the ratio of the Claims(annual growth as % of broad money) in Hungary in 2002 to that in 2003?
Your response must be concise. 1.11. What is the ratio of the Claims(annual growth as % of broad money) in Sao Tome and Principe in 2002 to that in 2003?
Keep it short and to the point. 0.36. What is the ratio of the Claims(annual growth as % of broad money) in Botswana in 2002 to that in 2004?
Your answer should be compact. 1.03. What is the ratio of the Claims(annual growth as % of broad money) in Colombia in 2002 to that in 2004?
Give a very brief answer. 0.36. What is the ratio of the Claims(annual growth as % of broad money) in Hungary in 2002 to that in 2004?
Your answer should be very brief. 0.98. What is the ratio of the Claims(annual growth as % of broad money) of Sao Tome and Principe in 2002 to that in 2004?
Keep it short and to the point. 0.35. What is the ratio of the Claims(annual growth as % of broad money) of Botswana in 2002 to that in 2005?
Provide a succinct answer. 2.54. What is the ratio of the Claims(annual growth as % of broad money) in Colombia in 2002 to that in 2005?
Provide a short and direct response. 0.54. What is the ratio of the Claims(annual growth as % of broad money) of Hungary in 2002 to that in 2005?
Your response must be concise. 0.88. What is the ratio of the Claims(annual growth as % of broad money) of Sao Tome and Principe in 2002 to that in 2005?
Provide a succinct answer. 0.2. What is the ratio of the Claims(annual growth as % of broad money) of Botswana in 2002 to that in 2006?
Provide a succinct answer. 1.13. What is the ratio of the Claims(annual growth as % of broad money) of Colombia in 2002 to that in 2006?
Provide a short and direct response. 0.2. What is the ratio of the Claims(annual growth as % of broad money) of Hungary in 2002 to that in 2006?
Give a very brief answer. 0.9. What is the ratio of the Claims(annual growth as % of broad money) in Sao Tome and Principe in 2002 to that in 2006?
Offer a very short reply. 0.29. What is the ratio of the Claims(annual growth as % of broad money) in Botswana in 2002 to that in 2007?
Ensure brevity in your answer.  0.82. What is the ratio of the Claims(annual growth as % of broad money) in Colombia in 2002 to that in 2007?
Ensure brevity in your answer.  0.24. What is the ratio of the Claims(annual growth as % of broad money) in Hungary in 2002 to that in 2007?
Your response must be concise. 0.81. What is the ratio of the Claims(annual growth as % of broad money) in Sao Tome and Principe in 2002 to that in 2007?
Provide a short and direct response. 0.35. What is the ratio of the Claims(annual growth as % of broad money) in Botswana in 2003 to that in 2004?
Ensure brevity in your answer.  0.51. What is the ratio of the Claims(annual growth as % of broad money) in Colombia in 2003 to that in 2004?
Your response must be concise. 0.47. What is the ratio of the Claims(annual growth as % of broad money) in Hungary in 2003 to that in 2004?
Offer a terse response. 0.88. What is the ratio of the Claims(annual growth as % of broad money) of Sao Tome and Principe in 2003 to that in 2004?
Provide a succinct answer. 0.99. What is the ratio of the Claims(annual growth as % of broad money) in Botswana in 2003 to that in 2005?
Keep it short and to the point. 1.24. What is the ratio of the Claims(annual growth as % of broad money) of Colombia in 2003 to that in 2005?
Your answer should be very brief. 0.71. What is the ratio of the Claims(annual growth as % of broad money) in Hungary in 2003 to that in 2005?
Your response must be concise. 0.79. What is the ratio of the Claims(annual growth as % of broad money) in Sao Tome and Principe in 2003 to that in 2005?
Make the answer very short. 0.56. What is the ratio of the Claims(annual growth as % of broad money) of Botswana in 2003 to that in 2006?
Your answer should be very brief. 0.55. What is the ratio of the Claims(annual growth as % of broad money) in Colombia in 2003 to that in 2006?
Give a very brief answer. 0.26. What is the ratio of the Claims(annual growth as % of broad money) in Hungary in 2003 to that in 2006?
Give a very brief answer. 0.81. What is the ratio of the Claims(annual growth as % of broad money) of Sao Tome and Principe in 2003 to that in 2006?
Provide a short and direct response. 0.81. What is the ratio of the Claims(annual growth as % of broad money) of Botswana in 2003 to that in 2007?
Your answer should be compact. 0.4. What is the ratio of the Claims(annual growth as % of broad money) of Colombia in 2003 to that in 2007?
Ensure brevity in your answer.  0.32. What is the ratio of the Claims(annual growth as % of broad money) in Hungary in 2003 to that in 2007?
Offer a terse response. 0.73. What is the ratio of the Claims(annual growth as % of broad money) in Sao Tome and Principe in 2003 to that in 2007?
Give a very brief answer. 0.98. What is the ratio of the Claims(annual growth as % of broad money) in Botswana in 2004 to that in 2005?
Offer a very short reply. 2.45. What is the ratio of the Claims(annual growth as % of broad money) in Colombia in 2004 to that in 2005?
Offer a terse response. 1.51. What is the ratio of the Claims(annual growth as % of broad money) in Hungary in 2004 to that in 2005?
Give a very brief answer. 0.89. What is the ratio of the Claims(annual growth as % of broad money) of Sao Tome and Principe in 2004 to that in 2005?
Offer a very short reply. 0.56. What is the ratio of the Claims(annual growth as % of broad money) of Botswana in 2004 to that in 2006?
Make the answer very short. 1.09. What is the ratio of the Claims(annual growth as % of broad money) of Colombia in 2004 to that in 2006?
Give a very brief answer. 0.56. What is the ratio of the Claims(annual growth as % of broad money) in Hungary in 2004 to that in 2006?
Your answer should be compact. 0.91. What is the ratio of the Claims(annual growth as % of broad money) in Sao Tome and Principe in 2004 to that in 2006?
Offer a terse response. 0.82. What is the ratio of the Claims(annual growth as % of broad money) in Botswana in 2004 to that in 2007?
Your answer should be very brief. 0.8. What is the ratio of the Claims(annual growth as % of broad money) in Colombia in 2004 to that in 2007?
Your response must be concise. 0.68. What is the ratio of the Claims(annual growth as % of broad money) in Hungary in 2004 to that in 2007?
Give a very brief answer. 0.82. What is the ratio of the Claims(annual growth as % of broad money) of Sao Tome and Principe in 2004 to that in 2007?
Provide a short and direct response. 0.98. What is the ratio of the Claims(annual growth as % of broad money) in Botswana in 2005 to that in 2006?
Ensure brevity in your answer.  0.45. What is the ratio of the Claims(annual growth as % of broad money) in Colombia in 2005 to that in 2006?
Your response must be concise. 0.37. What is the ratio of the Claims(annual growth as % of broad money) in Hungary in 2005 to that in 2006?
Ensure brevity in your answer.  1.02. What is the ratio of the Claims(annual growth as % of broad money) in Sao Tome and Principe in 2005 to that in 2006?
Provide a succinct answer. 1.46. What is the ratio of the Claims(annual growth as % of broad money) in Botswana in 2005 to that in 2007?
Ensure brevity in your answer.  0.32. What is the ratio of the Claims(annual growth as % of broad money) of Colombia in 2005 to that in 2007?
Make the answer very short. 0.45. What is the ratio of the Claims(annual growth as % of broad money) in Hungary in 2005 to that in 2007?
Your answer should be very brief. 0.92. What is the ratio of the Claims(annual growth as % of broad money) of Sao Tome and Principe in 2005 to that in 2007?
Provide a succinct answer. 1.75. What is the ratio of the Claims(annual growth as % of broad money) of Botswana in 2006 to that in 2007?
Make the answer very short. 0.73. What is the ratio of the Claims(annual growth as % of broad money) of Colombia in 2006 to that in 2007?
Provide a short and direct response. 1.21. What is the ratio of the Claims(annual growth as % of broad money) of Hungary in 2006 to that in 2007?
Offer a terse response. 0.9. What is the ratio of the Claims(annual growth as % of broad money) in Sao Tome and Principe in 2006 to that in 2007?
Make the answer very short. 1.2. What is the difference between the highest and the second highest Claims(annual growth as % of broad money) of Botswana?
Provide a short and direct response. 2.24. What is the difference between the highest and the second highest Claims(annual growth as % of broad money) in Colombia?
Make the answer very short. 4.56. What is the difference between the highest and the second highest Claims(annual growth as % of broad money) in Hungary?
Your answer should be compact. 1.3. What is the difference between the highest and the second highest Claims(annual growth as % of broad money) of Sao Tome and Principe?
Offer a terse response. 15.12. What is the difference between the highest and the lowest Claims(annual growth as % of broad money) of Botswana?
Make the answer very short. 8.56. What is the difference between the highest and the lowest Claims(annual growth as % of broad money) of Colombia?
Make the answer very short. 21.01. What is the difference between the highest and the lowest Claims(annual growth as % of broad money) of Hungary?
Offer a very short reply. 4.65. What is the difference between the highest and the lowest Claims(annual growth as % of broad money) in Sao Tome and Principe?
Your answer should be compact. 38.73. 